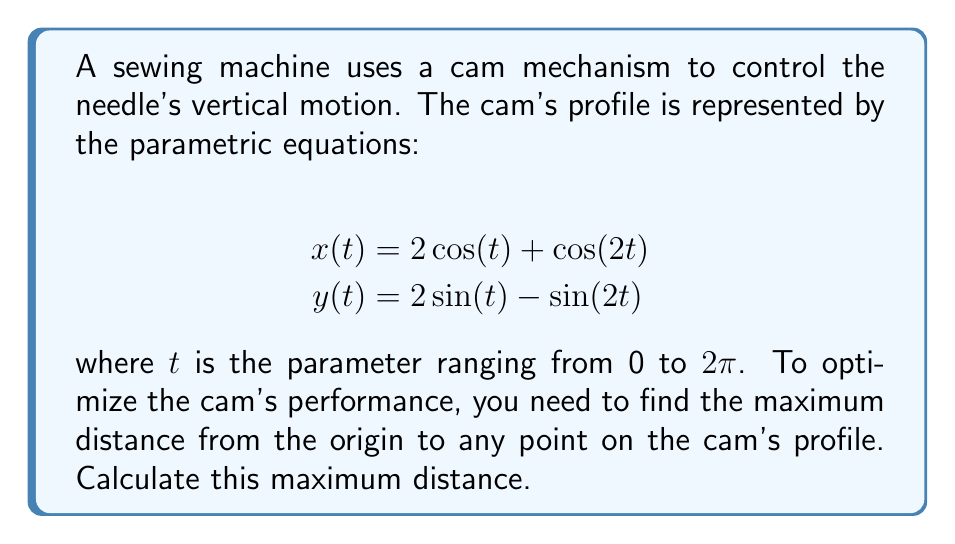Provide a solution to this math problem. To find the maximum distance from the origin to any point on the cam's profile, we need to follow these steps:

1) The distance from the origin to any point $(x,y)$ is given by $\sqrt{x^2 + y^2}$. In our case, this becomes:

   $$r(t) = \sqrt{x(t)^2 + y(t)^2}$$

2) Substitute the given parametric equations:

   $$r(t) = \sqrt{(2\cos(t) + \cos(2t))^2 + (2\sin(t) - \sin(2t))^2}$$

3) Expand the squares:

   $$r(t) = \sqrt{4\cos^2(t) + 4\cos(t)\cos(2t) + \cos^2(2t) + 4\sin^2(t) - 4\sin(t)\sin(2t) + \sin^2(2t)}$$

4) Use trigonometric identities:
   $\cos^2(t) + \sin^2(t) = 1$
   $\cos^2(2t) + \sin^2(2t) = 1$
   $\cos(2t) = \cos^2(t) - \sin^2(t)$
   $\sin(2t) = 2\sin(t)\cos(t)$

5) Simplify:

   $$r(t) = \sqrt{4 + 4(\cos^2(t) - \sin^2(t)) + 1}$$
   $$r(t) = \sqrt{5 + 4(\cos^2(t) - \sin^2(t))}$$

6) The maximum value of $\cos^2(t) - \sin^2(t)$ is 1 (when $t = 0$ or $\pi$), and its minimum value is -1 (when $t = \pi/2$ or $3\pi/2$).

7) Therefore, the maximum value of $r(t)$ occurs when $\cos^2(t) - \sin^2(t) = 1$:

   $$r_{max} = \sqrt{5 + 4(1)} = \sqrt{9} = 3$$

Thus, the maximum distance from the origin to any point on the cam's profile is 3 units.
Answer: The maximum distance from the origin to any point on the cam's profile is 3 units. 